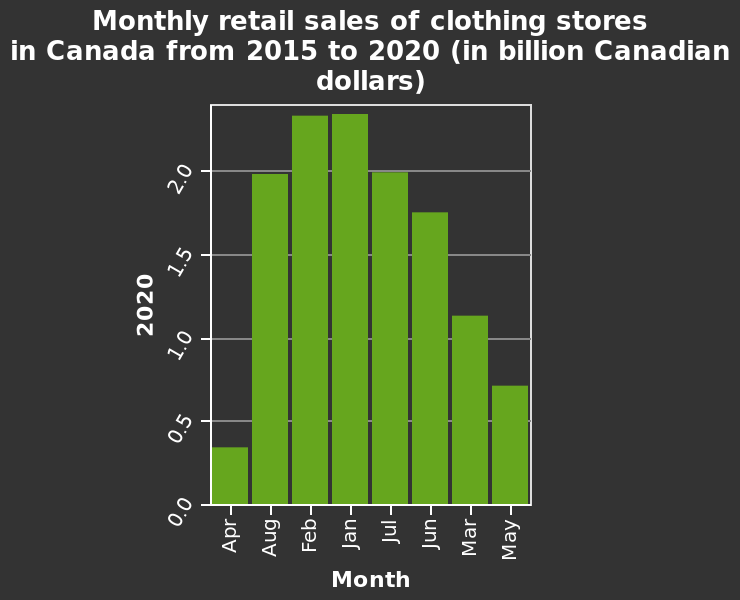<image>
How much sales did March have?  March had over 1 billion in sales. Offer a thorough analysis of the image. January and February had the highest sales with over 2 billion, June, July and August next with over 1 and a half billion, followed by March with over 1 billion then May with over half a billion then April having the lowest sales with under half a billion.  The majority of months made over 1 and a half billion. 